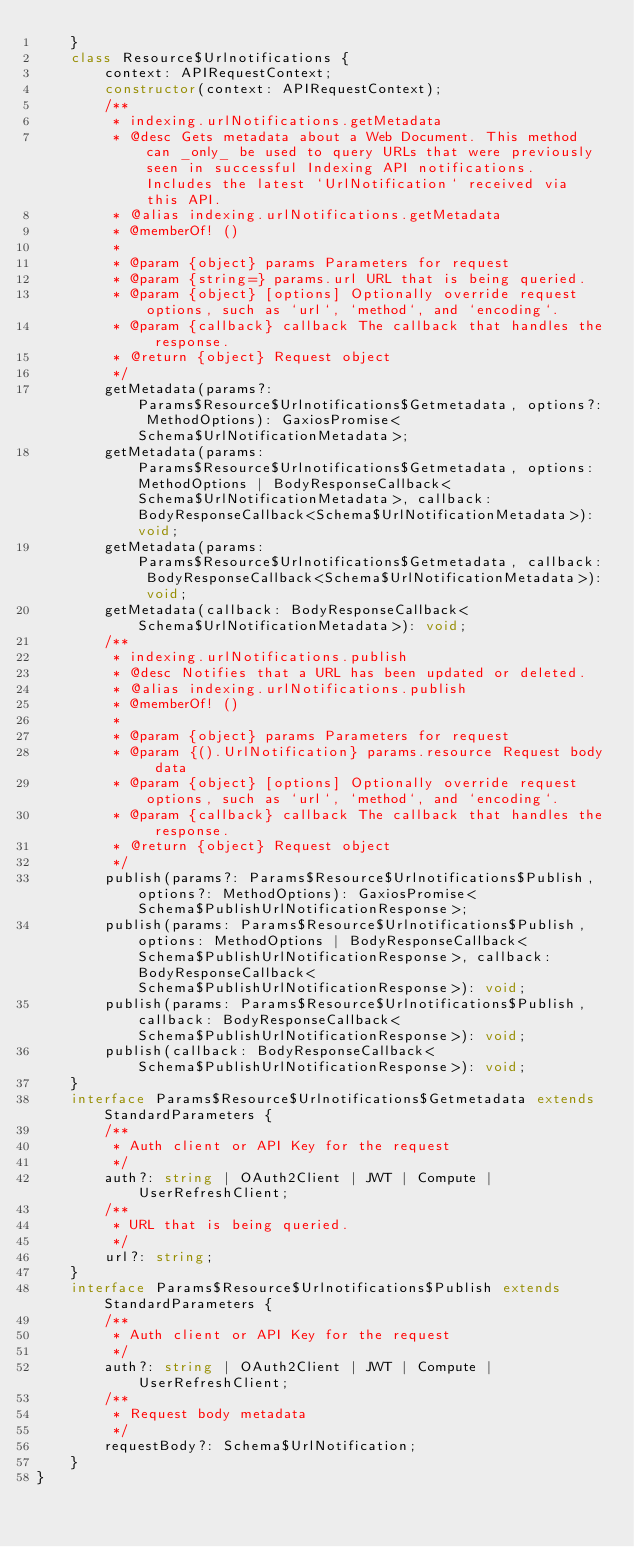<code> <loc_0><loc_0><loc_500><loc_500><_TypeScript_>    }
    class Resource$Urlnotifications {
        context: APIRequestContext;
        constructor(context: APIRequestContext);
        /**
         * indexing.urlNotifications.getMetadata
         * @desc Gets metadata about a Web Document. This method can _only_ be used to query URLs that were previously seen in successful Indexing API notifications. Includes the latest `UrlNotification` received via this API.
         * @alias indexing.urlNotifications.getMetadata
         * @memberOf! ()
         *
         * @param {object} params Parameters for request
         * @param {string=} params.url URL that is being queried.
         * @param {object} [options] Optionally override request options, such as `url`, `method`, and `encoding`.
         * @param {callback} callback The callback that handles the response.
         * @return {object} Request object
         */
        getMetadata(params?: Params$Resource$Urlnotifications$Getmetadata, options?: MethodOptions): GaxiosPromise<Schema$UrlNotificationMetadata>;
        getMetadata(params: Params$Resource$Urlnotifications$Getmetadata, options: MethodOptions | BodyResponseCallback<Schema$UrlNotificationMetadata>, callback: BodyResponseCallback<Schema$UrlNotificationMetadata>): void;
        getMetadata(params: Params$Resource$Urlnotifications$Getmetadata, callback: BodyResponseCallback<Schema$UrlNotificationMetadata>): void;
        getMetadata(callback: BodyResponseCallback<Schema$UrlNotificationMetadata>): void;
        /**
         * indexing.urlNotifications.publish
         * @desc Notifies that a URL has been updated or deleted.
         * @alias indexing.urlNotifications.publish
         * @memberOf! ()
         *
         * @param {object} params Parameters for request
         * @param {().UrlNotification} params.resource Request body data
         * @param {object} [options] Optionally override request options, such as `url`, `method`, and `encoding`.
         * @param {callback} callback The callback that handles the response.
         * @return {object} Request object
         */
        publish(params?: Params$Resource$Urlnotifications$Publish, options?: MethodOptions): GaxiosPromise<Schema$PublishUrlNotificationResponse>;
        publish(params: Params$Resource$Urlnotifications$Publish, options: MethodOptions | BodyResponseCallback<Schema$PublishUrlNotificationResponse>, callback: BodyResponseCallback<Schema$PublishUrlNotificationResponse>): void;
        publish(params: Params$Resource$Urlnotifications$Publish, callback: BodyResponseCallback<Schema$PublishUrlNotificationResponse>): void;
        publish(callback: BodyResponseCallback<Schema$PublishUrlNotificationResponse>): void;
    }
    interface Params$Resource$Urlnotifications$Getmetadata extends StandardParameters {
        /**
         * Auth client or API Key for the request
         */
        auth?: string | OAuth2Client | JWT | Compute | UserRefreshClient;
        /**
         * URL that is being queried.
         */
        url?: string;
    }
    interface Params$Resource$Urlnotifications$Publish extends StandardParameters {
        /**
         * Auth client or API Key for the request
         */
        auth?: string | OAuth2Client | JWT | Compute | UserRefreshClient;
        /**
         * Request body metadata
         */
        requestBody?: Schema$UrlNotification;
    }
}
</code> 